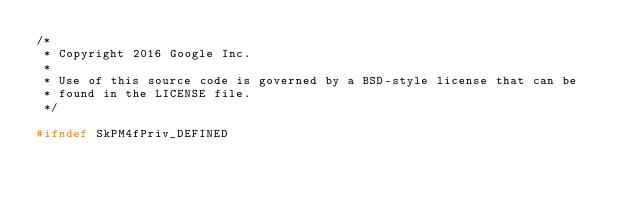<code> <loc_0><loc_0><loc_500><loc_500><_C_>/*
 * Copyright 2016 Google Inc.
 *
 * Use of this source code is governed by a BSD-style license that can be
 * found in the LICENSE file.
 */

#ifndef SkPM4fPriv_DEFINED</code> 